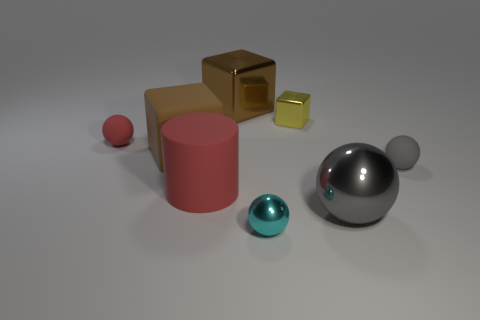Subtract all brown balls. How many brown cubes are left? 2 Subtract all cyan balls. How many balls are left? 3 Subtract 2 spheres. How many spheres are left? 2 Subtract all small spheres. How many spheres are left? 1 Add 1 small cyan objects. How many objects exist? 9 Subtract all purple balls. Subtract all brown cylinders. How many balls are left? 4 Subtract all cylinders. How many objects are left? 7 Subtract all small gray blocks. Subtract all large red cylinders. How many objects are left? 7 Add 4 yellow objects. How many yellow objects are left? 5 Add 4 small things. How many small things exist? 8 